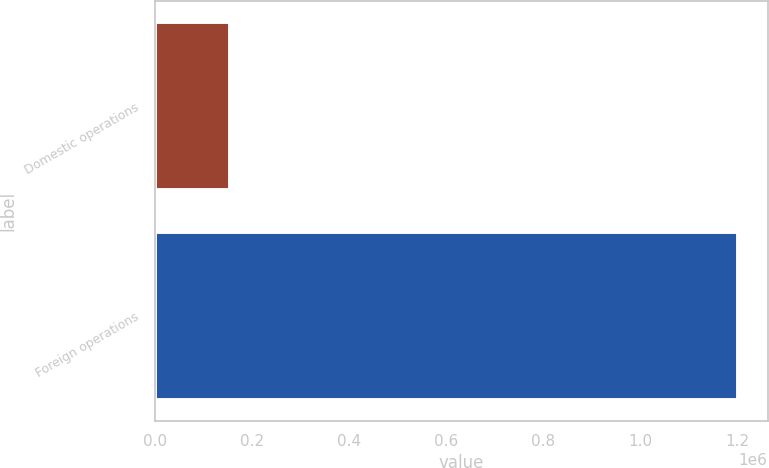<chart> <loc_0><loc_0><loc_500><loc_500><bar_chart><fcel>Domestic operations<fcel>Foreign operations<nl><fcel>155296<fcel>1.20154e+06<nl></chart> 